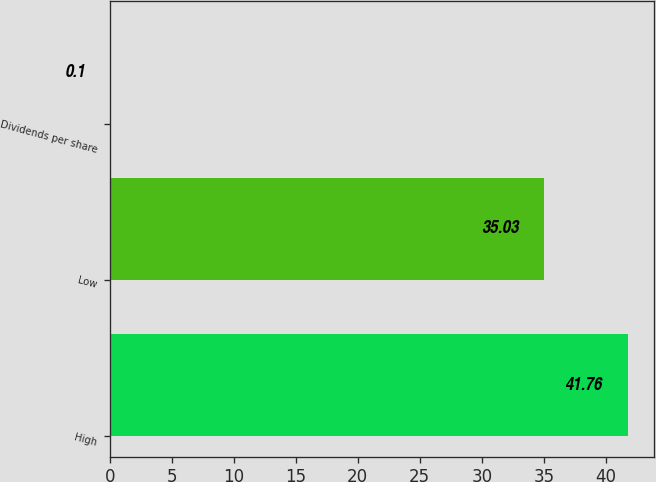Convert chart to OTSL. <chart><loc_0><loc_0><loc_500><loc_500><bar_chart><fcel>High<fcel>Low<fcel>Dividends per share<nl><fcel>41.76<fcel>35.03<fcel>0.1<nl></chart> 